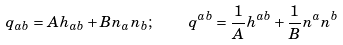<formula> <loc_0><loc_0><loc_500><loc_500>q _ { a b } = A h _ { a b } + B n _ { a } n _ { b } ; \quad q ^ { a b } = \frac { 1 } { A } h ^ { a b } + \frac { 1 } { B } n ^ { a } n ^ { b }</formula> 